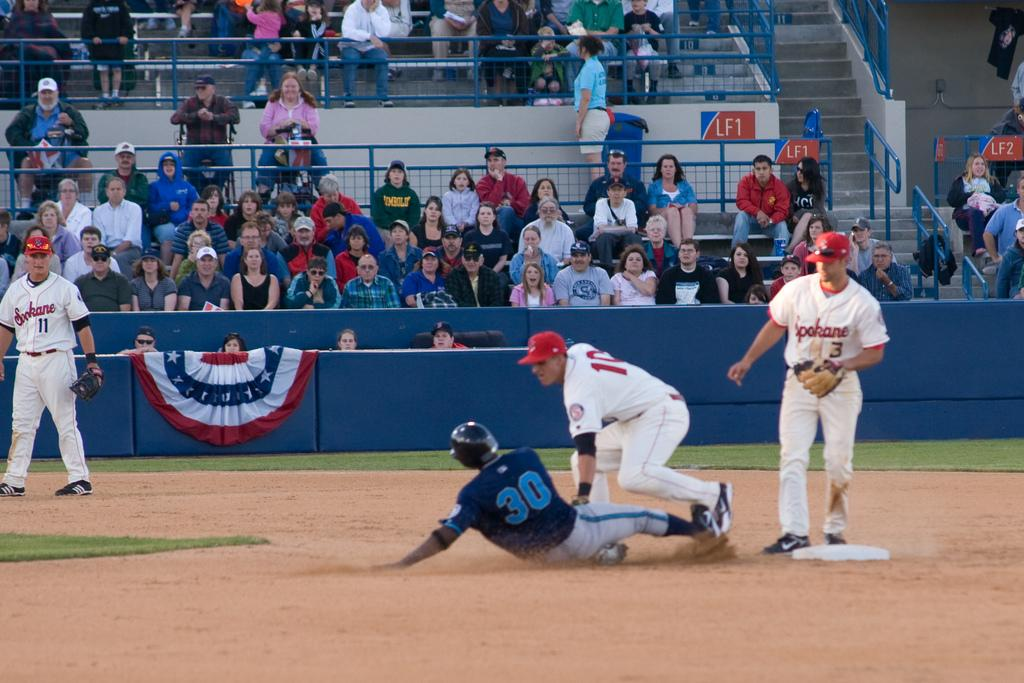Provide a one-sentence caption for the provided image. number 30 of the blue team is sliding to base. 